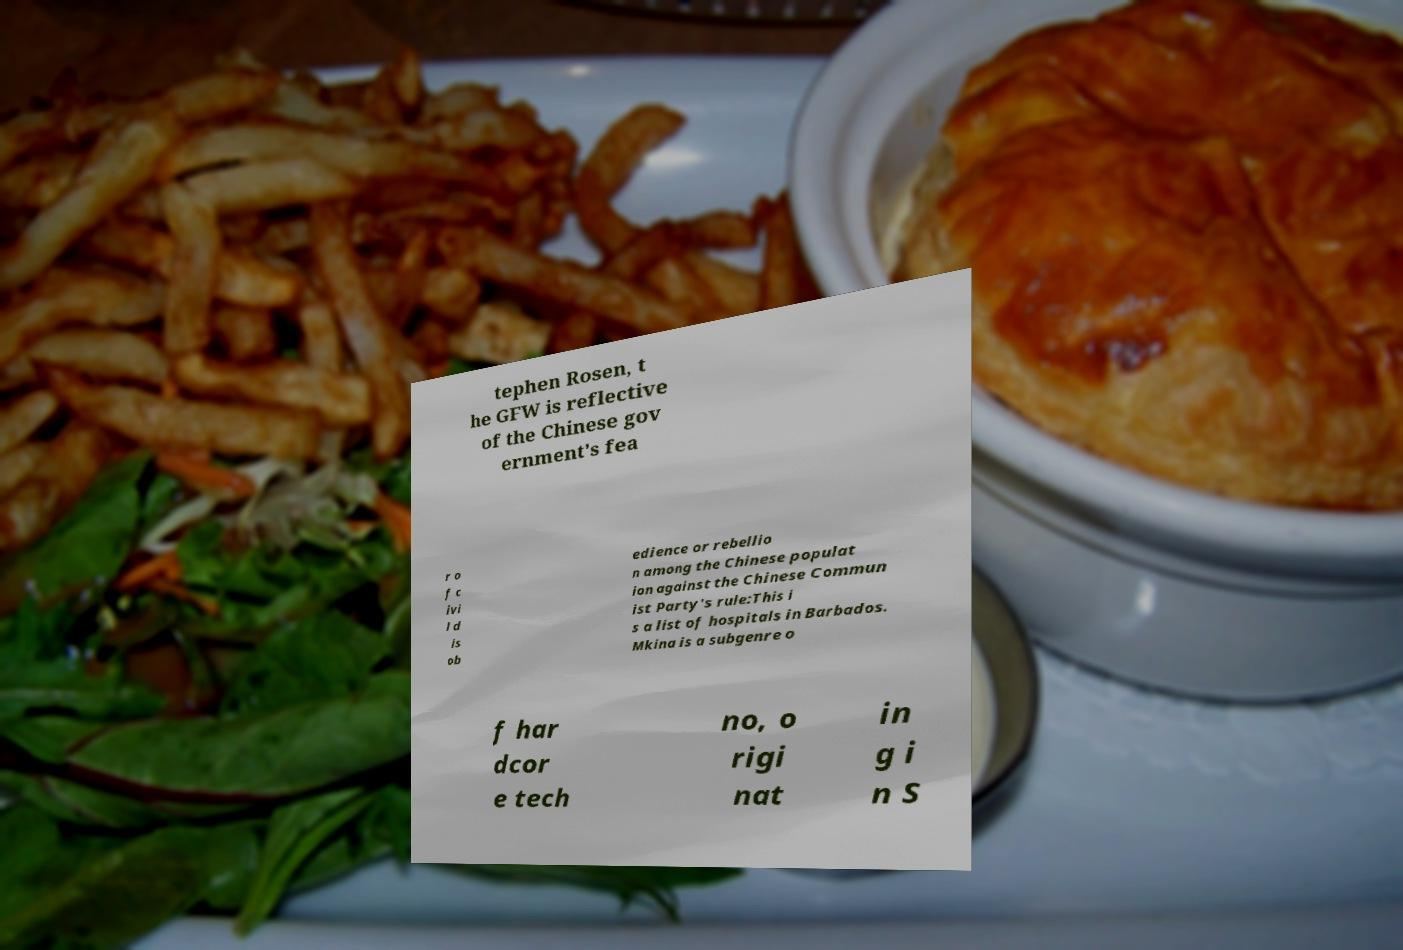Please read and relay the text visible in this image. What does it say? tephen Rosen, t he GFW is reflective of the Chinese gov ernment's fea r o f c ivi l d is ob edience or rebellio n among the Chinese populat ion against the Chinese Commun ist Party's rule:This i s a list of hospitals in Barbados. Mkina is a subgenre o f har dcor e tech no, o rigi nat in g i n S 